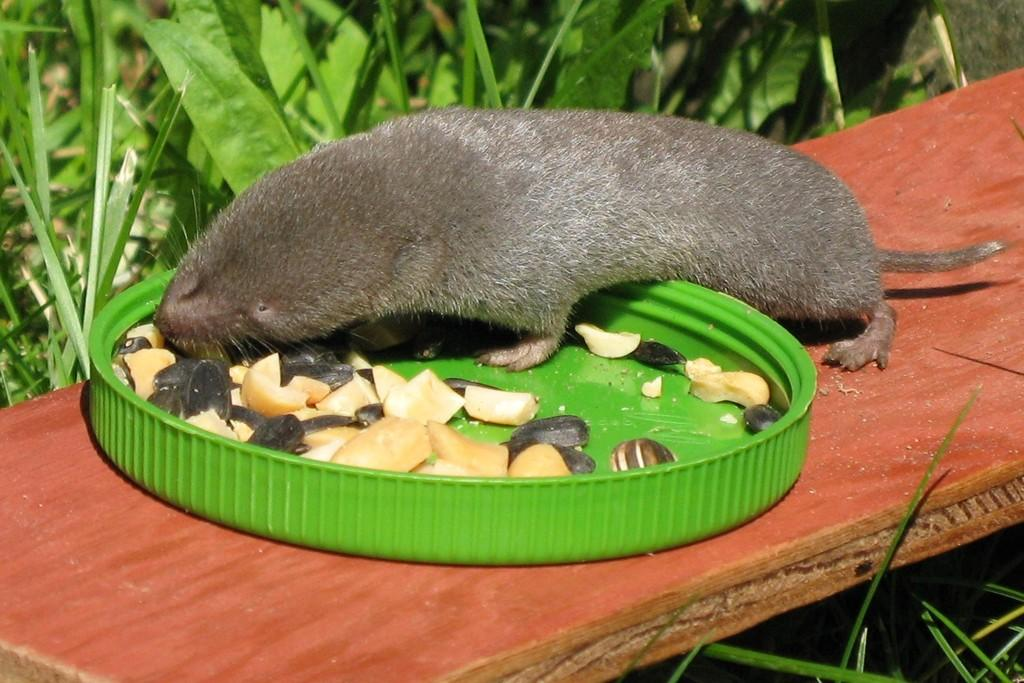What color is the lid that is visible in the image? There is a green color lid in the image. What is placed on the lid in the image? Food items are kept on the lid. What can be seen on the wooden plank in the image? There is a rat on a wooden plank in the image. What type of vegetation is visible in the background of the image? Grass and small plants are present in the background of the image. What type of committee is meeting with the stranger in the image? There is no committee or stranger present in the image; it features a green lid with food items, a rat on a wooden plank, and grass and small plants in the background. 